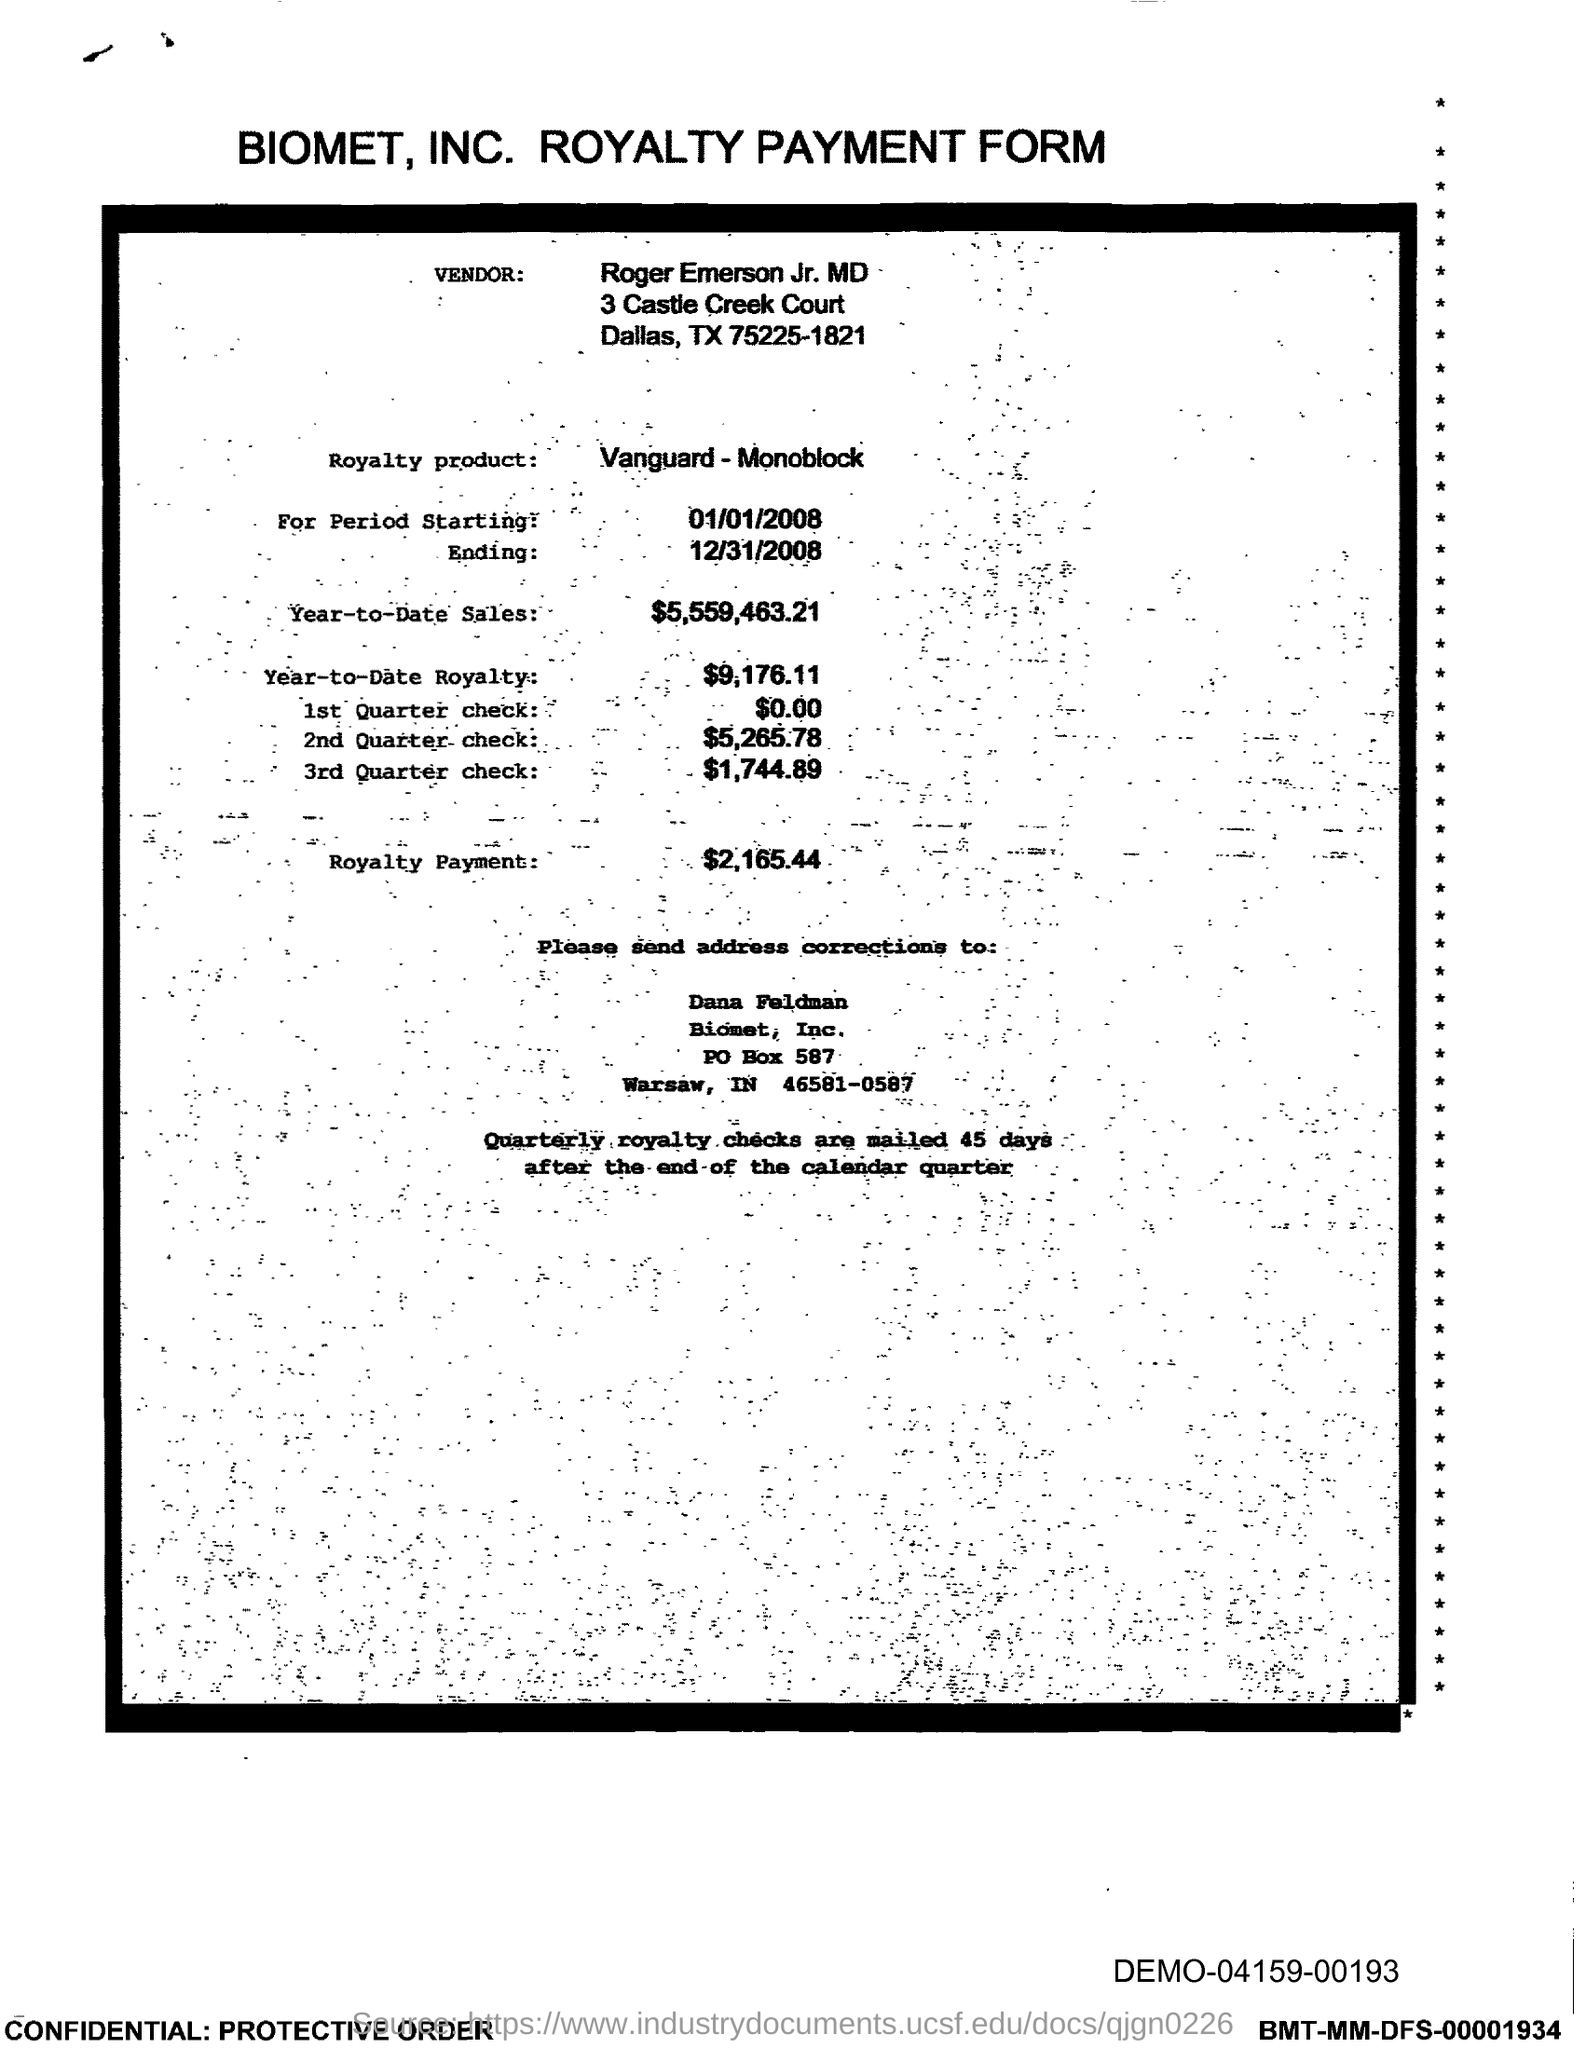In which state is biomet, inc. located ?
Keep it short and to the point. IN. What is the po box no. of biomet, inc.?
Your answer should be compact. 587. What is the year-to-date sales?
Offer a very short reply. $5,559,463.21. What is the year-to-date royalty ?
Offer a terse response. $9,176.11. What is the royalty payment ?
Keep it short and to the point. $2,165.44. 